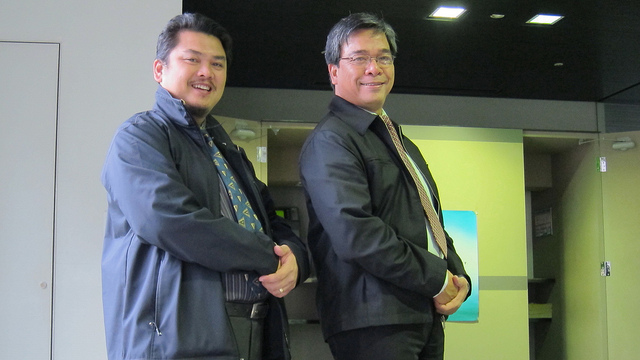<image>Who has the better looking tie? I am not sure who has the better looking tie. It could be the man on the left or the man on the right. Who has the better looking tie? I don't know who has the better looking tie. It can be either the man on the left or the man on the right. 